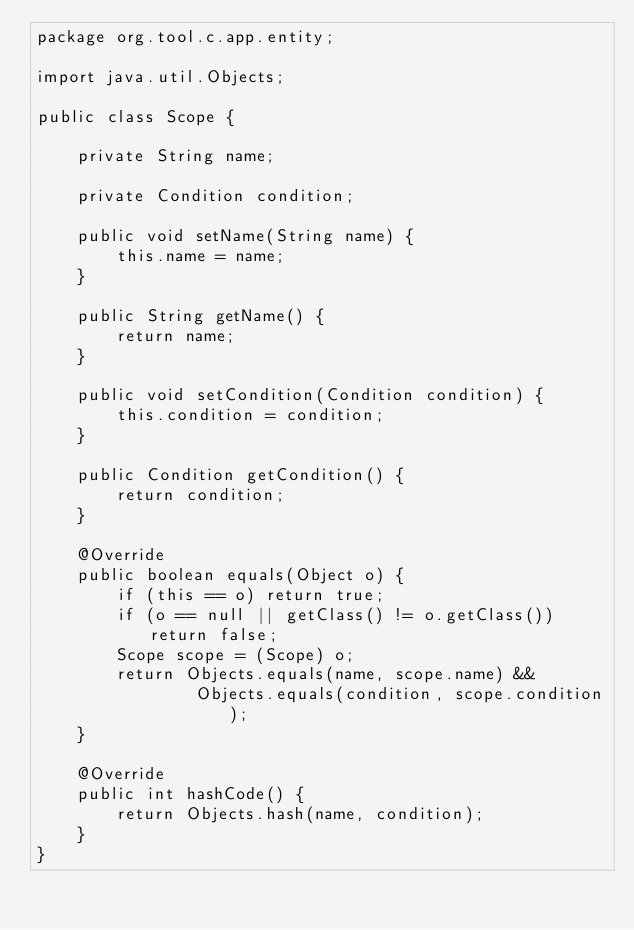Convert code to text. <code><loc_0><loc_0><loc_500><loc_500><_Java_>package org.tool.c.app.entity;

import java.util.Objects;

public class Scope {

    private String name;

    private Condition condition;

    public void setName(String name) {
        this.name = name;
    }

    public String getName() {
        return name;
    }

    public void setCondition(Condition condition) {
        this.condition = condition;
    }

    public Condition getCondition() {
        return condition;
    }

    @Override
    public boolean equals(Object o) {
        if (this == o) return true;
        if (o == null || getClass() != o.getClass()) return false;
        Scope scope = (Scope) o;
        return Objects.equals(name, scope.name) &&
                Objects.equals(condition, scope.condition);
    }

    @Override
    public int hashCode() {
        return Objects.hash(name, condition);
    }
}
</code> 